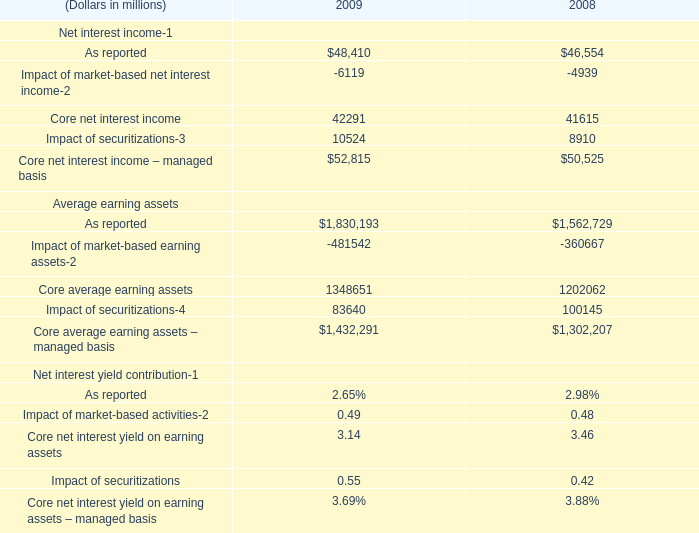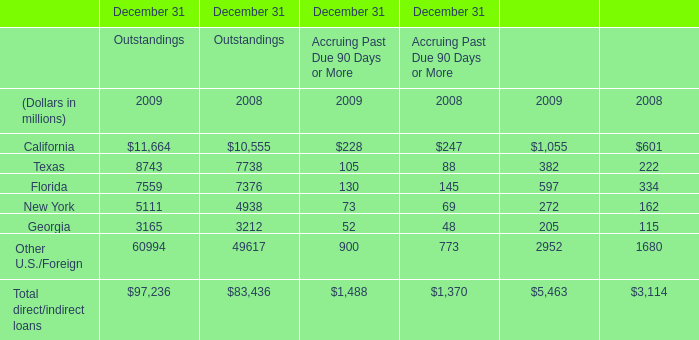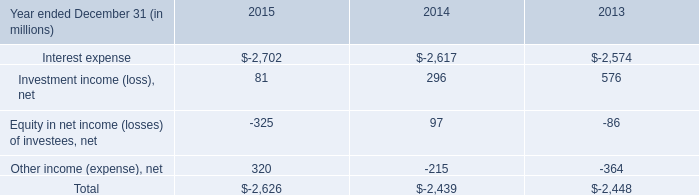what's the total amount of Impact of securitizations of 2008, and Texas of December 31 Outstandings 2009 ? 
Computations: (8910.0 + 8743.0)
Answer: 17653.0. 